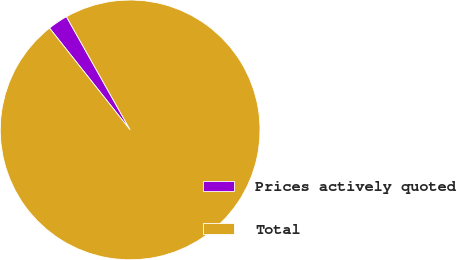Convert chart to OTSL. <chart><loc_0><loc_0><loc_500><loc_500><pie_chart><fcel>Prices actively quoted<fcel>Total<nl><fcel>2.5%<fcel>97.5%<nl></chart> 